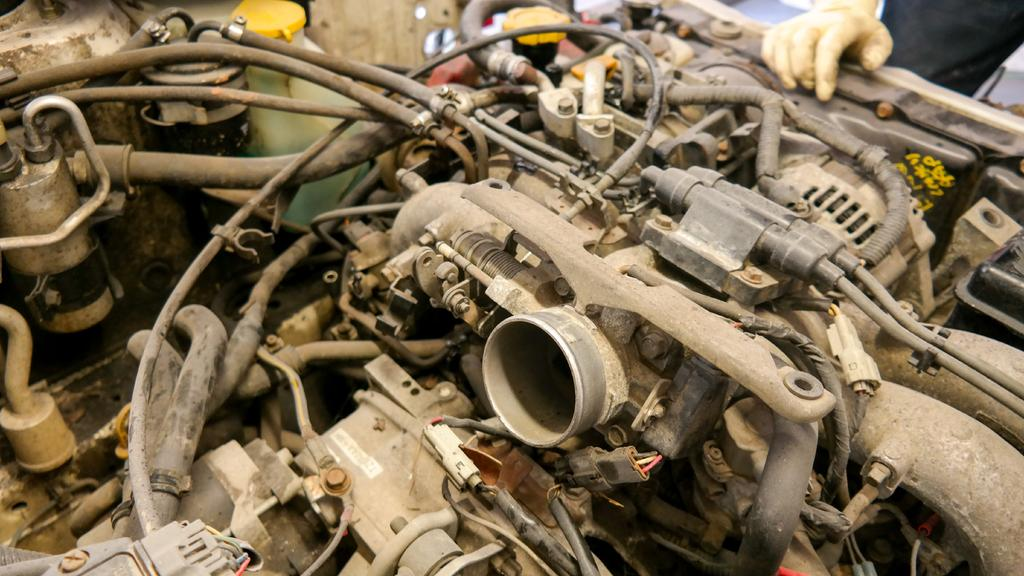What is the main object in the image? There is a machine in the image. What else can be seen in the image besides the machine? There are wires and a human in the image. What is the human doing in the image? A human hand is on the machine in the image. How many jars are on the machine in the image? There are no jars present in the image. What type of frog can be seen sitting on the human's shoulder in the image? There is no frog present in the image. 